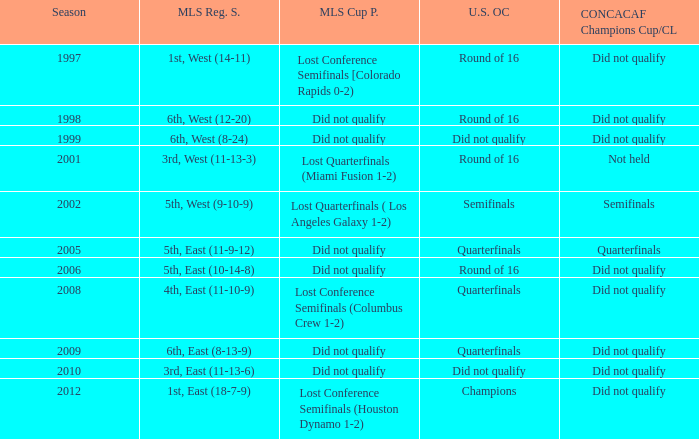How did the team place when they did not qualify for the Concaf Champions Cup but made it to Round of 16 in the U.S. Open Cup? Lost Conference Semifinals [Colorado Rapids 0-2), Did not qualify, Did not qualify. 